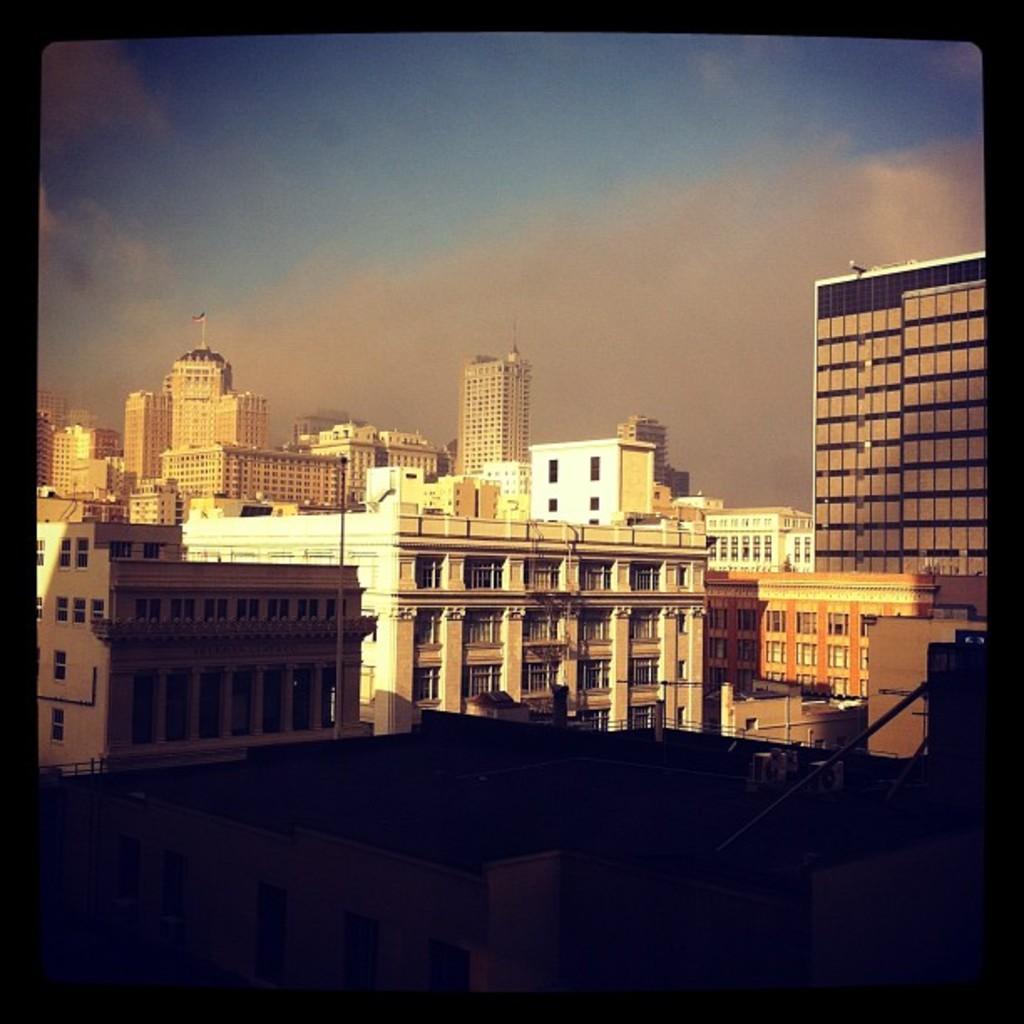Could you give a brief overview of what you see in this image? In this picture, there are buildings with windows. On the top, there is a sky with clouds. 